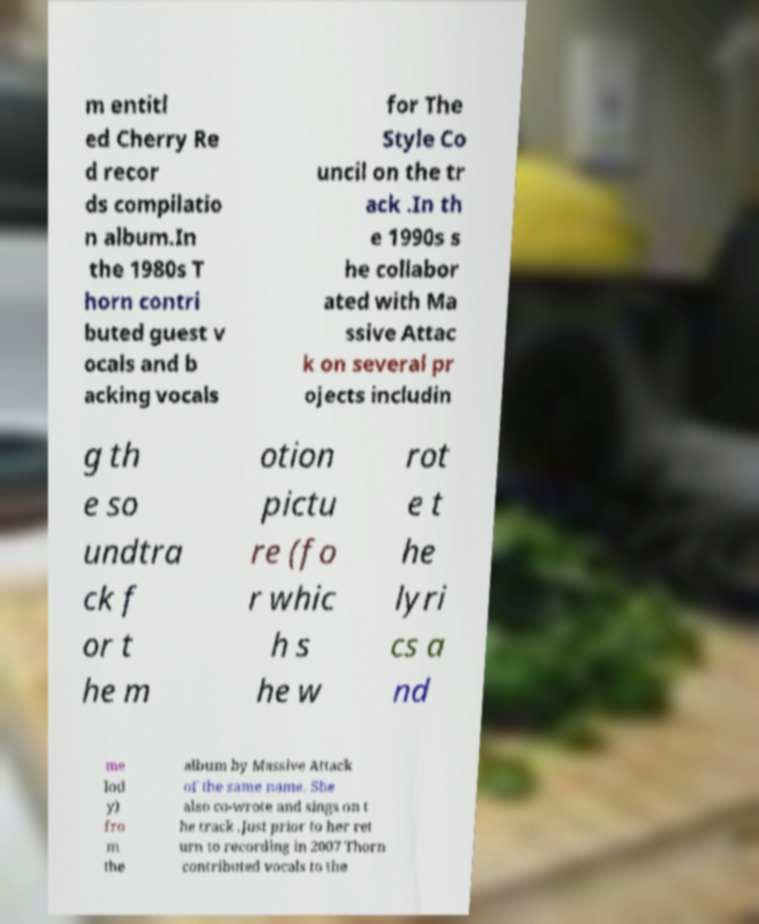Can you read and provide the text displayed in the image?This photo seems to have some interesting text. Can you extract and type it out for me? m entitl ed Cherry Re d recor ds compilatio n album.In the 1980s T horn contri buted guest v ocals and b acking vocals for The Style Co uncil on the tr ack .In th e 1990s s he collabor ated with Ma ssive Attac k on several pr ojects includin g th e so undtra ck f or t he m otion pictu re (fo r whic h s he w rot e t he lyri cs a nd me lod y) fro m the album by Massive Attack of the same name. She also co-wrote and sings on t he track .Just prior to her ret urn to recording in 2007 Thorn contributed vocals to the 